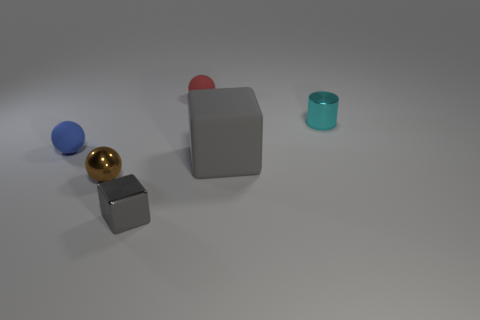Add 1 large matte blocks. How many objects exist? 7 Subtract all cubes. How many objects are left? 4 Subtract all red matte objects. Subtract all tiny brown shiny spheres. How many objects are left? 4 Add 5 small shiny cubes. How many small shiny cubes are left? 6 Add 5 small gray shiny spheres. How many small gray shiny spheres exist? 5 Subtract 0 blue cubes. How many objects are left? 6 